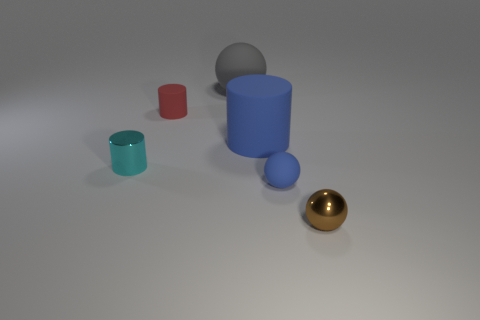Add 4 large red things. How many objects exist? 10 Subtract all cyan things. Subtract all metallic cylinders. How many objects are left? 4 Add 1 small red matte cylinders. How many small red matte cylinders are left? 2 Add 5 purple metal cubes. How many purple metal cubes exist? 5 Subtract 0 yellow cylinders. How many objects are left? 6 